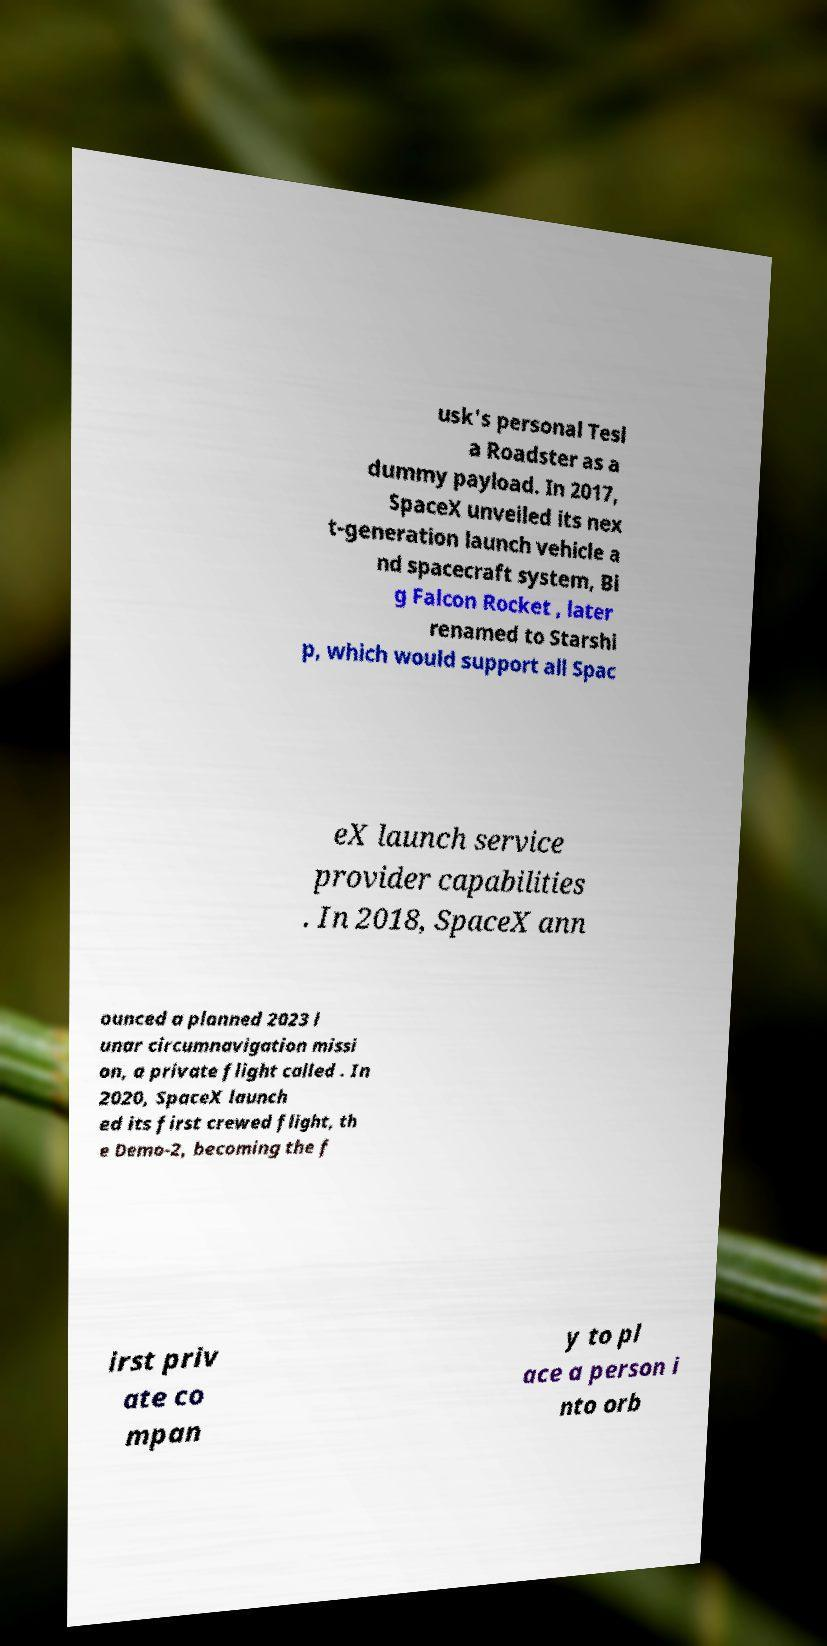Could you extract and type out the text from this image? usk's personal Tesl a Roadster as a dummy payload. In 2017, SpaceX unveiled its nex t-generation launch vehicle a nd spacecraft system, Bi g Falcon Rocket , later renamed to Starshi p, which would support all Spac eX launch service provider capabilities . In 2018, SpaceX ann ounced a planned 2023 l unar circumnavigation missi on, a private flight called . In 2020, SpaceX launch ed its first crewed flight, th e Demo-2, becoming the f irst priv ate co mpan y to pl ace a person i nto orb 